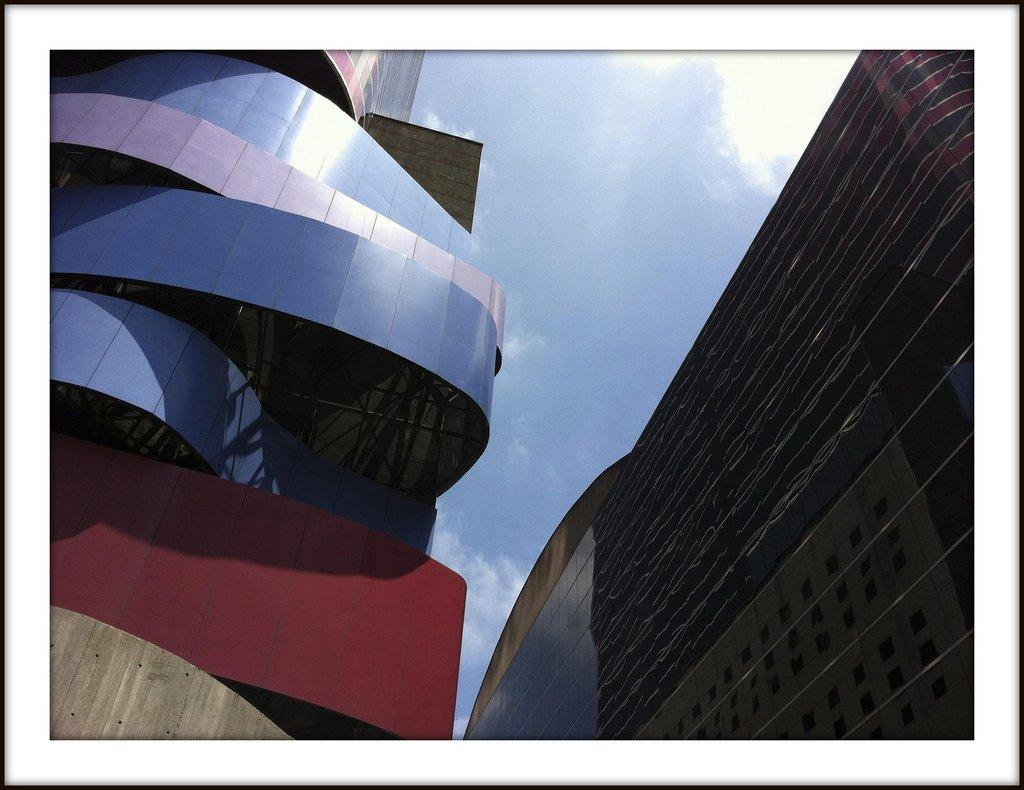What type of structure is visible in the image? There is a building in the image. What feature can be observed on the building? The building has glass windows. What is the condition of the sky in the image? The sky is clear in the image. What type of fuel is being used by the desk in the image? There is no desk present in the image, so it is not possible to determine what type of fuel it might use. 